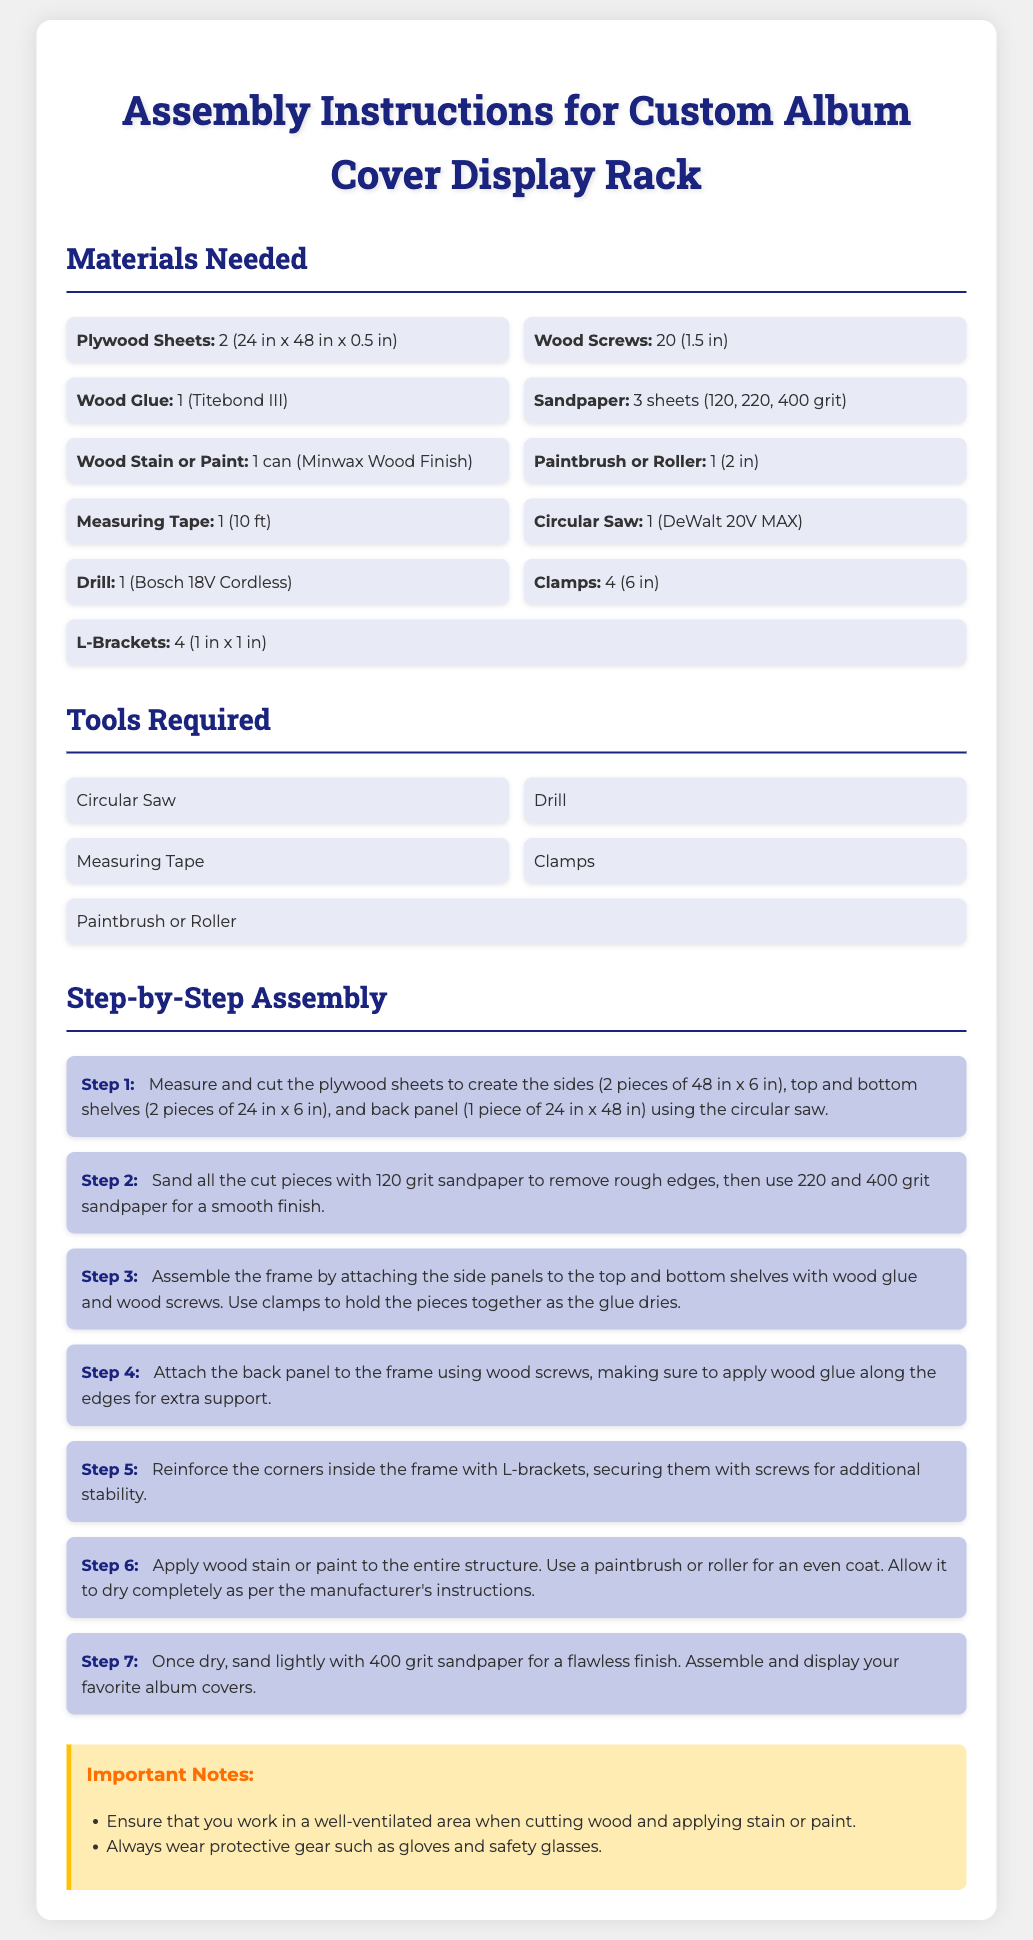What is the size of the plywood sheets needed? The document specifies the need for plywood sheets sized 24 in x 48 in x 0.5 in.
Answer: 24 in x 48 in x 0.5 in How many wood screws are required? The document states that 20 wood screws of length 1.5 in are needed for the assembly.
Answer: 20 What type of wood glue is recommended? The document recommends Titebond III wood glue for assembly.
Answer: Titebond III What length should the side panels be cut to? According to the assembly instructions, the side panels should be cut to 48 in in length.
Answer: 48 in Why is sandpaper of multiple grits mentioned? Sandpaper of 120, 220, and 400 grit is mentioned for progressive smoothing of the cut pieces.
Answer: For progressive smoothing What assembly step involves using clamps? Clamps are used in Step 3 to hold the pieces together while the glue dries.
Answer: Step 3 How many L-brackets are needed for reinforcement? The document specifies that 4 L-brackets are needed to reinforce the corners.
Answer: 4 What is the purpose of applying wood stain or paint? The purpose is to finish the entire structure and enhance its appearance.
Answer: To finish and enhance appearance What safety equipment should be worn while working? It’s important to wear gloves and safety glasses for protection during assembly.
Answer: Gloves and safety glasses 